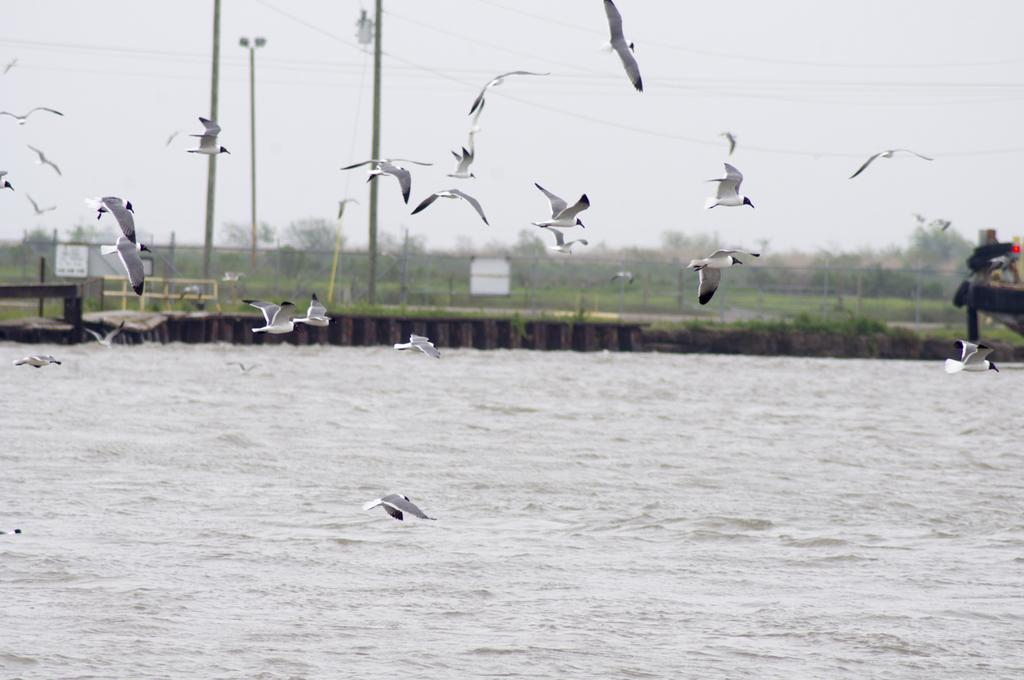What type of animals can be seen in the image? There are white color birds flying in the air. What can be seen in the background of the image? Water, a fence, trees, wires attached to poles, and other unspecified objects can be seen in the background. What part of the natural environment is visible in the image? Water and trees are visible in the background. What is visible in the sky in the image? The sky is visible in the background. Can you see a bucket being used by the birds in the image? There is no bucket present in the image. Are the birds jumping in the air in the image? The image does not show the birds jumping; they are simply flying. 